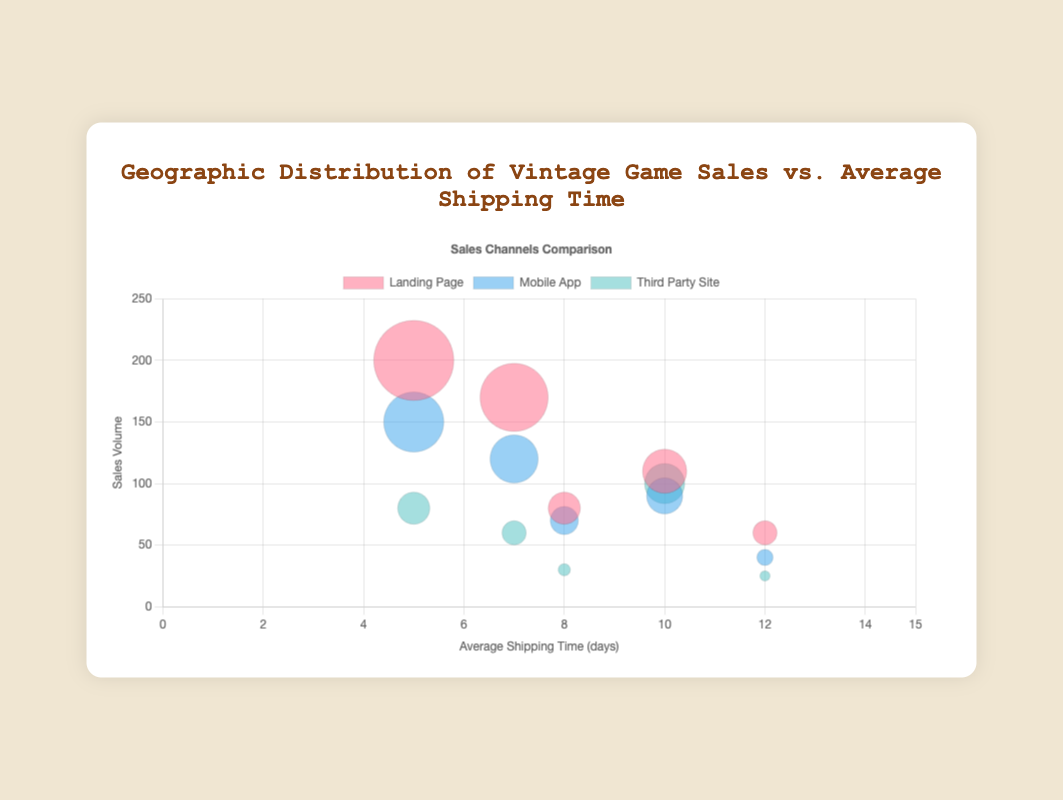What's the title of the bubble chart? The title is located at the top of the chart, which directly provides the name of the chart.
Answer: Geographic Distribution of Vintage Game Sales vs. Average Shipping Time How many regions are represented in the chart? Analyzing the different points plotted on the chart, each corresponds to a region, and since there are five sets of points (one for each sales channel per region), we can count the regions.
Answer: 5 Which region has the longest average shipping time? By looking at the x-axis representing average shipping time, the region furthest to the right indicates the longest average shipping time.
Answer: South America How does the sales volume from the landing page in North America compare to that of Europe? Find the data points for the landing page sales on the y-axis for both regions. North America's landing page sales point is higher compared to Europe.
Answer: North America has higher landing page sales than Europe What is the total sales volume for the mobile app in Asia? Locate the mobile app's sales point for Asia and perform a simple sum.
Answer: 90 Which sales channel has the smallest total sales in Australia? Identify and compare the bubble sizes in Australia, the one with the smallest radius represents the smallest sales volume.
Answer: Third Party Site What is the average sales volume for the landing page across all regions? Sum all the landing page sales volumes and divide by the number of regions. Calculation: (200 + 170 + 110 + 60 + 80) / 5 = 620 / 5
Answer: 124 Which region has the highest sales volume from third-party sites? Find and compare the y-values for the third-party site data points across all regions. Asia has the highest point.
Answer: Asia Between Europe and Australia, which region has faster shipping time? Compare the x-axis positions of the points for these regions; the one closer to the left has a faster shipping time.
Answer: Europe What’s the difference in sales volume between the mobile app and the third-party site in South America? Find and subtract the third-party site sales volume from the mobile app sales volume for South America. Calculation: 40 - 25
Answer: 15 